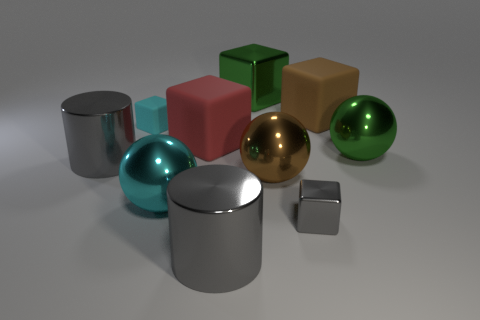Subtract 2 cubes. How many cubes are left? 3 Subtract all big green metallic cubes. How many cubes are left? 4 Subtract all gray cubes. How many cubes are left? 4 Subtract all yellow blocks. Subtract all gray balls. How many blocks are left? 5 Subtract all spheres. How many objects are left? 7 Subtract all small shiny objects. Subtract all large cyan metal spheres. How many objects are left? 8 Add 9 tiny matte objects. How many tiny matte objects are left? 10 Add 1 blocks. How many blocks exist? 6 Subtract 0 yellow spheres. How many objects are left? 10 